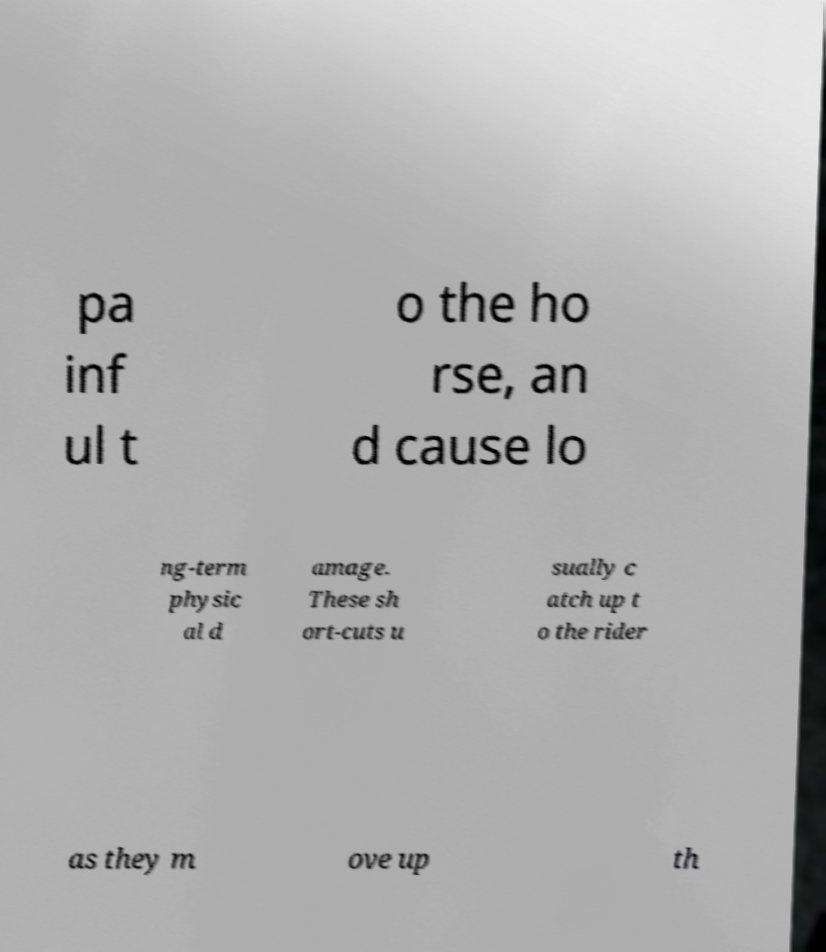There's text embedded in this image that I need extracted. Can you transcribe it verbatim? pa inf ul t o the ho rse, an d cause lo ng-term physic al d amage. These sh ort-cuts u sually c atch up t o the rider as they m ove up th 